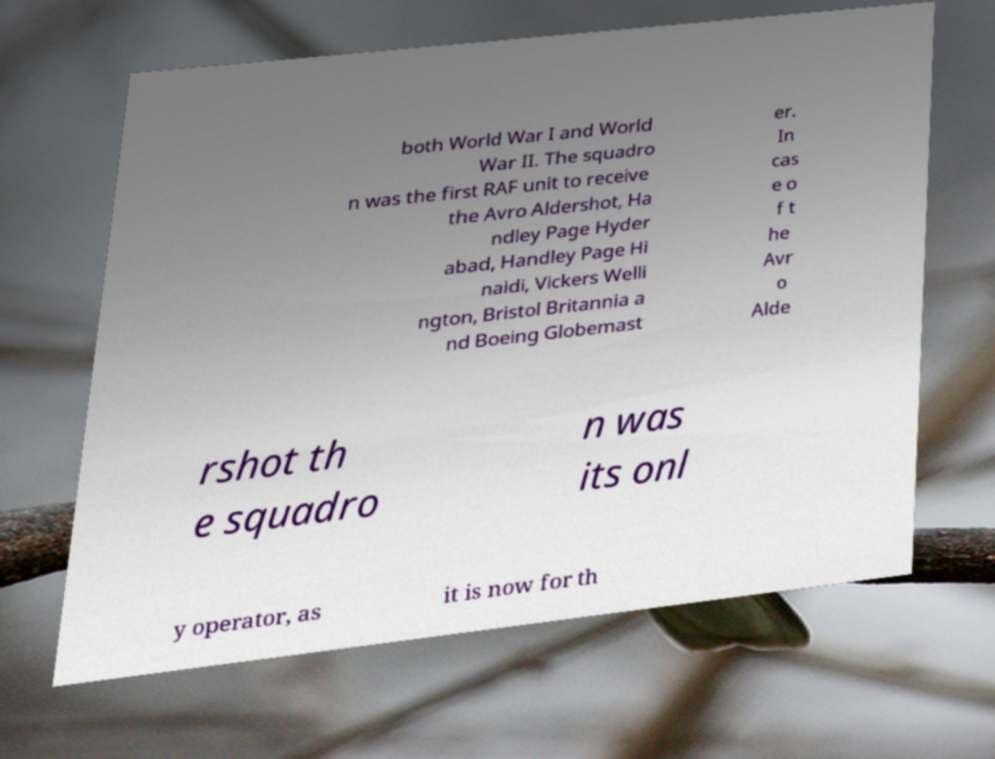For documentation purposes, I need the text within this image transcribed. Could you provide that? both World War I and World War II. The squadro n was the first RAF unit to receive the Avro Aldershot, Ha ndley Page Hyder abad, Handley Page Hi naidi, Vickers Welli ngton, Bristol Britannia a nd Boeing Globemast er. In cas e o f t he Avr o Alde rshot th e squadro n was its onl y operator, as it is now for th 